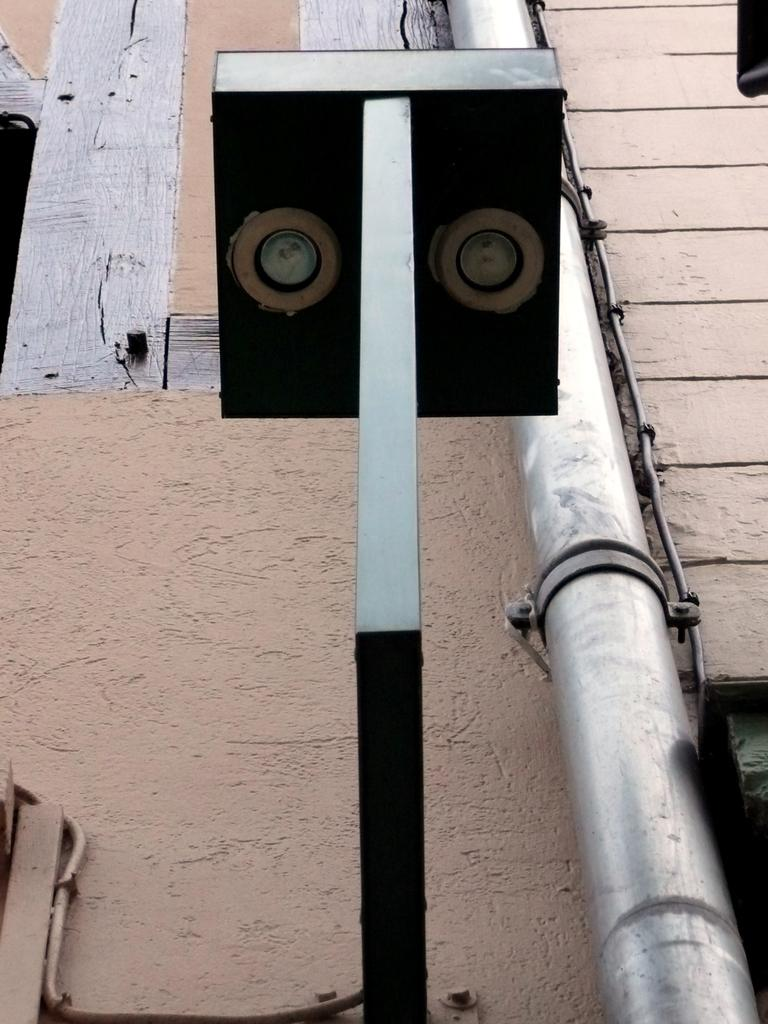What is the main object in the center of the image? There is a pole in the center of the image. What other object can be seen on the right side of the image? There is a pipe on the right side of the image. Can you describe the background of the image? It appears there is a wall in the image. How many pigs are visible in the image? There are no pigs present in the image. What type of yak can be seen driving the vehicle in the image? There is no vehicle or yak present in the image. 